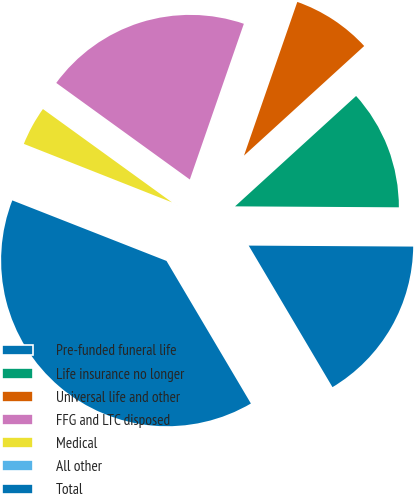Convert chart. <chart><loc_0><loc_0><loc_500><loc_500><pie_chart><fcel>Pre-funded funeral life<fcel>Life insurance no longer<fcel>Universal life and other<fcel>FFG and LTC disposed<fcel>Medical<fcel>All other<fcel>Total<nl><fcel>16.4%<fcel>11.86%<fcel>7.92%<fcel>20.35%<fcel>3.98%<fcel>0.03%<fcel>39.46%<nl></chart> 